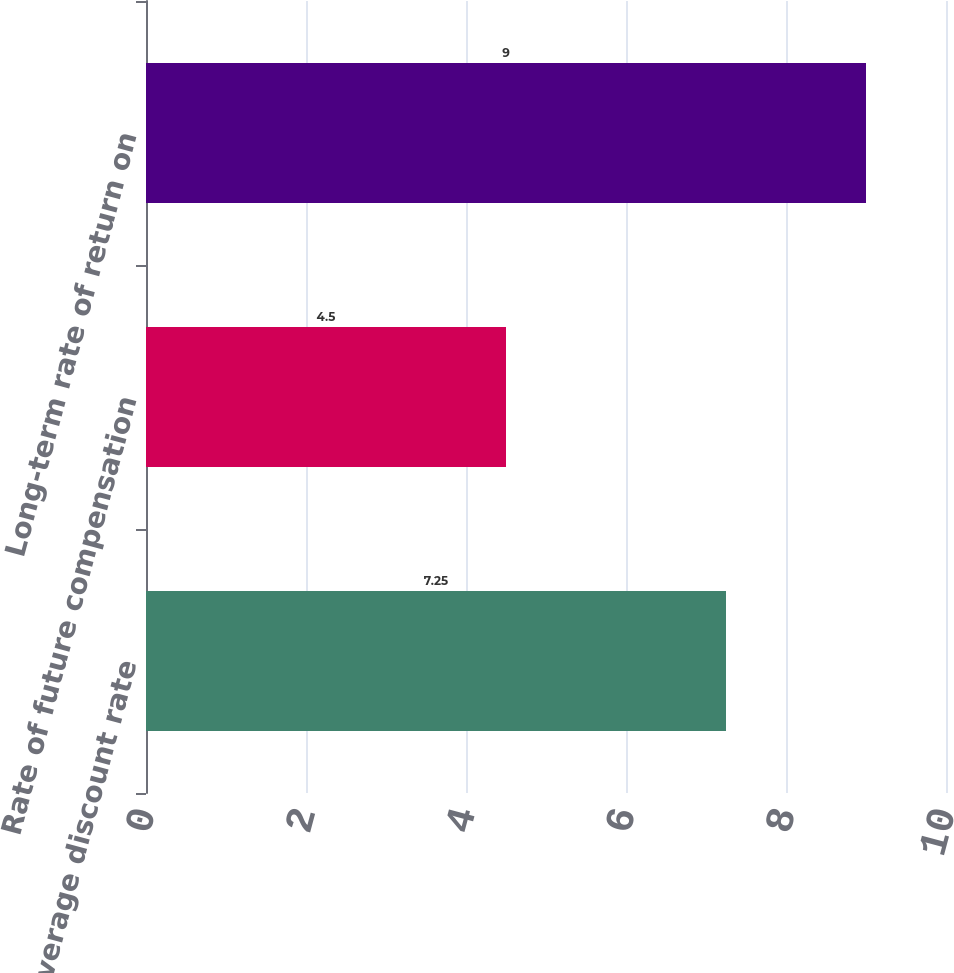Convert chart to OTSL. <chart><loc_0><loc_0><loc_500><loc_500><bar_chart><fcel>Weighted average discount rate<fcel>Rate of future compensation<fcel>Long-term rate of return on<nl><fcel>7.25<fcel>4.5<fcel>9<nl></chart> 